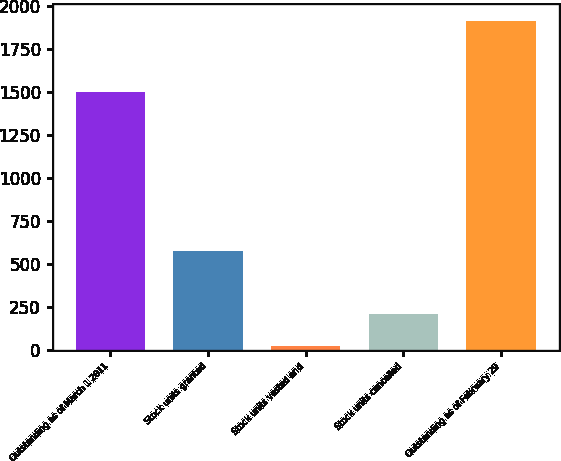Convert chart. <chart><loc_0><loc_0><loc_500><loc_500><bar_chart><fcel>Outstanding as of March 1 2011<fcel>Stock units granted<fcel>Stock units vested and<fcel>Stock units cancelled<fcel>Outstanding as of February 29<nl><fcel>1501<fcel>575<fcel>21<fcel>210.4<fcel>1915<nl></chart> 